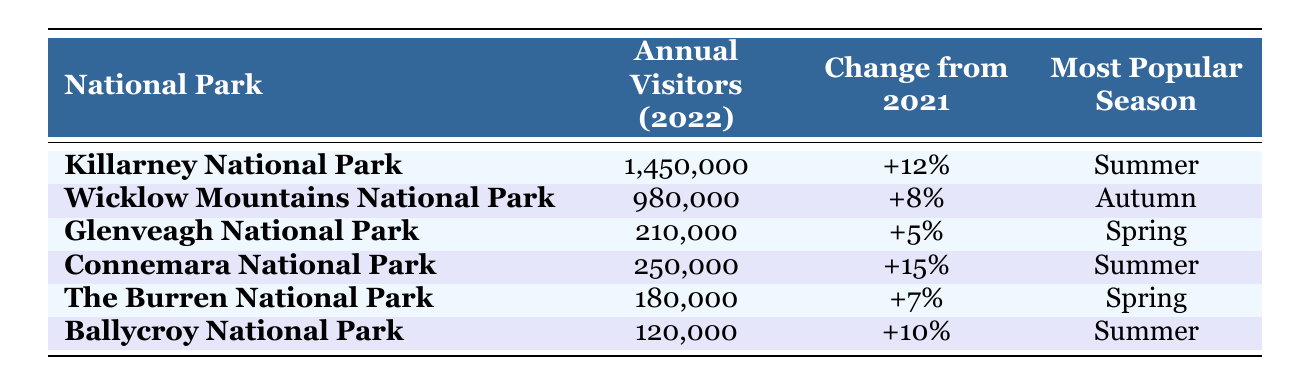What is the total number of annual visitors for all the national parks combined? To find the total number of annual visitors, sum the visitors for each park: 1,450,000 (Killarney) + 980,000 (Wicklow) + 210,000 (Glenveagh) + 250,000 (Connemara) + 180,000 (Burren) + 120,000 (Ballycroy) = 3,190,000.
Answer: 3,190,000 Which national park had the highest percentage change in visitors from 2021 to 2022? From the data, Connemara National Park had a +15% change, which is the highest among all parks.
Answer: Connemara National Park Is the most popular season for Glenveagh National Park Spring? Yes, Glenveagh National Park’s most popular season is indicated as Spring in the table.
Answer: Yes How many more visitors did Killarney National Park have than The Burren National Park in 2022? The difference in visitors is computed as follows: 1,450,000 (Killarney) - 180,000 (The Burren) = 1,270,000.
Answer: 1,270,000 What is the average number of annual visitors for the national parks listed? To calculate the average, first sum the visitors: 1,450,000 + 980,000 + 210,000 + 250,000 + 180,000 + 120,000 = 3,190,000. Then, divide by the number of parks (6): 3,190,000 / 6 = 531,666.67.
Answer: 531,666.67 Did Ballycroy National Park see a decrease in visitors compared to the previous year? No, Ballycroy National Park has an increase of +10% from the previous year according to the table.
Answer: No Which seasons are the most popular for the national parks listed in the table? The most popular seasons are: Summer (Killarney, Connemara, Ballycroy), Autumn (Wicklow), and Spring (Glenveagh, The Burren). This indicates a diversity in peak seasons among the parks.
Answer: Summer, Autumn, Spring What percentage change did The Burren National Park experience in visitors from 2021 to 2022? The table shows The Burren had a +7% change in visitors, which confirms the percentage change indicated.
Answer: +7% 